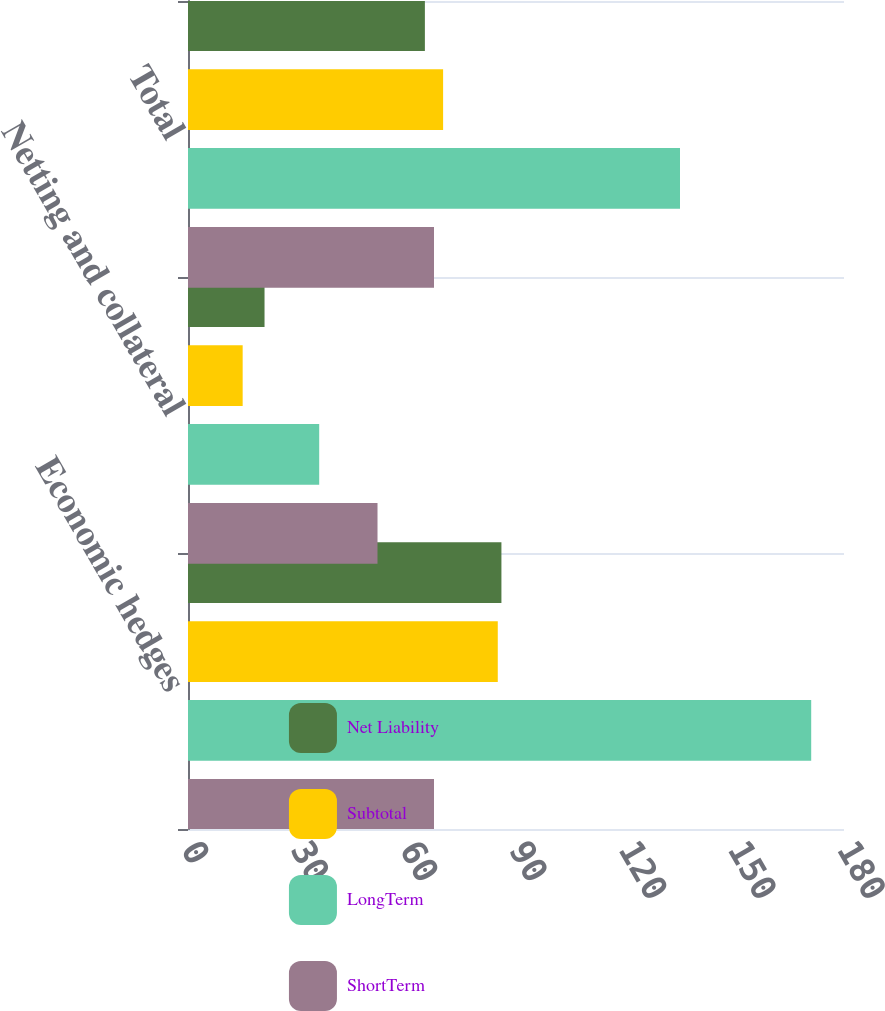Convert chart. <chart><loc_0><loc_0><loc_500><loc_500><stacked_bar_chart><ecel><fcel>Economic hedges<fcel>Netting and collateral<fcel>Total<nl><fcel>Net Liability<fcel>86<fcel>21<fcel>65<nl><fcel>Subtotal<fcel>85<fcel>15<fcel>70<nl><fcel>LongTerm<fcel>171<fcel>36<fcel>135<nl><fcel>ShortTerm<fcel>67.5<fcel>52<fcel>67.5<nl></chart> 